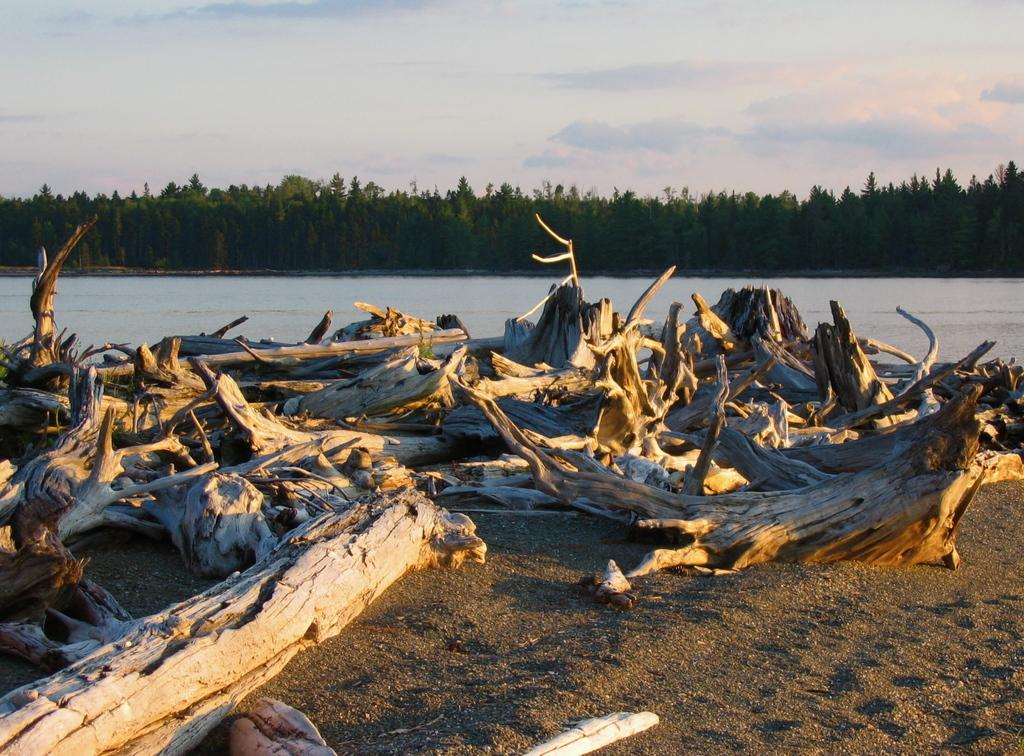What type of vegetation can be seen in the image? There are trees in the image. What natural element is visible in the image? There is water visible in the image. What part of the natural environment is visible in the image? The sky is visible in the image. What type of bit can be seen in the image? There is no bit present in the image. What hobbies are the trees in the image participating in? Trees do not have hobbies, as they are inanimate objects. Is there a volcano visible in the image? There is no volcano present in the image. 